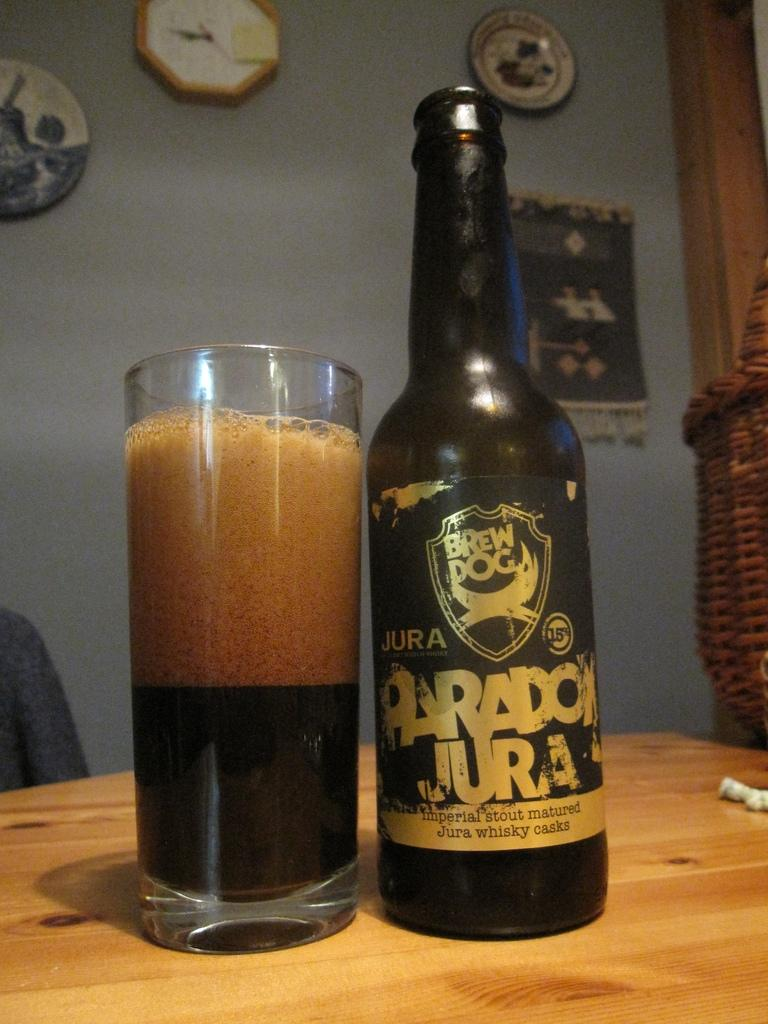<image>
Give a short and clear explanation of the subsequent image. A bottle of BrewDog Paradox Jura beer sits on a table next to a partly filled glass. 